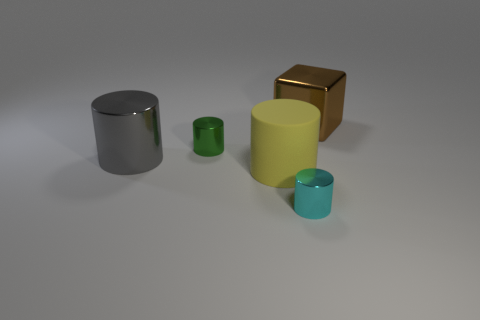Add 4 gray metallic cylinders. How many objects exist? 9 Subtract all blue cylinders. Subtract all gray cubes. How many cylinders are left? 4 Subtract all cylinders. How many objects are left? 1 Subtract all cyan cylinders. Subtract all yellow balls. How many objects are left? 4 Add 1 small cyan metallic things. How many small cyan metallic things are left? 2 Add 5 big shiny cylinders. How many big shiny cylinders exist? 6 Subtract 0 red balls. How many objects are left? 5 